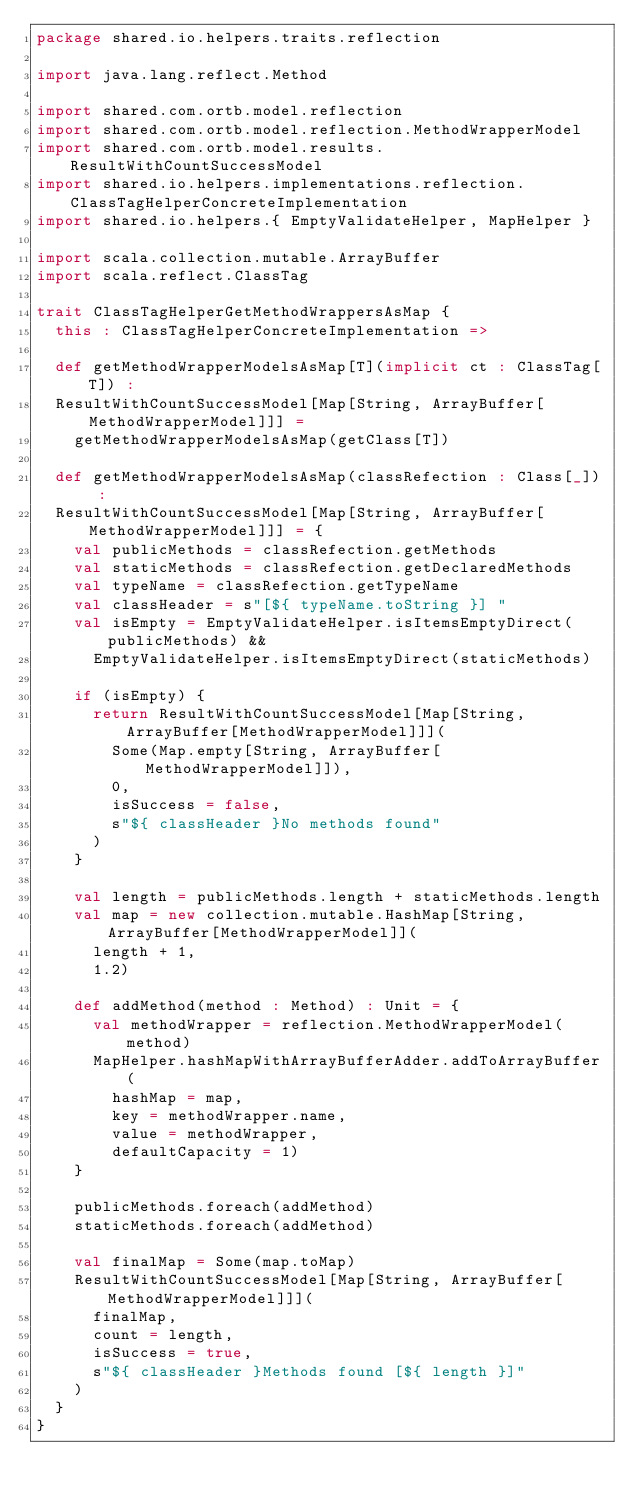Convert code to text. <code><loc_0><loc_0><loc_500><loc_500><_Scala_>package shared.io.helpers.traits.reflection

import java.lang.reflect.Method

import shared.com.ortb.model.reflection
import shared.com.ortb.model.reflection.MethodWrapperModel
import shared.com.ortb.model.results.ResultWithCountSuccessModel
import shared.io.helpers.implementations.reflection.ClassTagHelperConcreteImplementation
import shared.io.helpers.{ EmptyValidateHelper, MapHelper }

import scala.collection.mutable.ArrayBuffer
import scala.reflect.ClassTag

trait ClassTagHelperGetMethodWrappersAsMap {
  this : ClassTagHelperConcreteImplementation =>

  def getMethodWrapperModelsAsMap[T](implicit ct : ClassTag[T]) :
  ResultWithCountSuccessModel[Map[String, ArrayBuffer[MethodWrapperModel]]] =
    getMethodWrapperModelsAsMap(getClass[T])

  def getMethodWrapperModelsAsMap(classRefection : Class[_]) :
  ResultWithCountSuccessModel[Map[String, ArrayBuffer[MethodWrapperModel]]] = {
    val publicMethods = classRefection.getMethods
    val staticMethods = classRefection.getDeclaredMethods
    val typeName = classRefection.getTypeName
    val classHeader = s"[${ typeName.toString }] "
    val isEmpty = EmptyValidateHelper.isItemsEmptyDirect(publicMethods) &&
      EmptyValidateHelper.isItemsEmptyDirect(staticMethods)

    if (isEmpty) {
      return ResultWithCountSuccessModel[Map[String, ArrayBuffer[MethodWrapperModel]]](
        Some(Map.empty[String, ArrayBuffer[MethodWrapperModel]]),
        0,
        isSuccess = false,
        s"${ classHeader }No methods found"
      )
    }

    val length = publicMethods.length + staticMethods.length
    val map = new collection.mutable.HashMap[String, ArrayBuffer[MethodWrapperModel]](
      length + 1,
      1.2)

    def addMethod(method : Method) : Unit = {
      val methodWrapper = reflection.MethodWrapperModel(method)
      MapHelper.hashMapWithArrayBufferAdder.addToArrayBuffer(
        hashMap = map,
        key = methodWrapper.name,
        value = methodWrapper,
        defaultCapacity = 1)
    }

    publicMethods.foreach(addMethod)
    staticMethods.foreach(addMethod)

    val finalMap = Some(map.toMap)
    ResultWithCountSuccessModel[Map[String, ArrayBuffer[MethodWrapperModel]]](
      finalMap,
      count = length,
      isSuccess = true,
      s"${ classHeader }Methods found [${ length }]"
    )
  }
}
</code> 